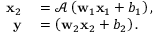Convert formula to latex. <formula><loc_0><loc_0><loc_500><loc_500>\begin{array} { r l } { x _ { 2 } } & = \mathcal { A } \left ( w _ { 1 } x _ { 1 } + b _ { 1 } \right ) , } \\ { y } & = \left ( w _ { 2 } x _ { 2 } + b _ { 2 } \right ) . } \end{array}</formula> 